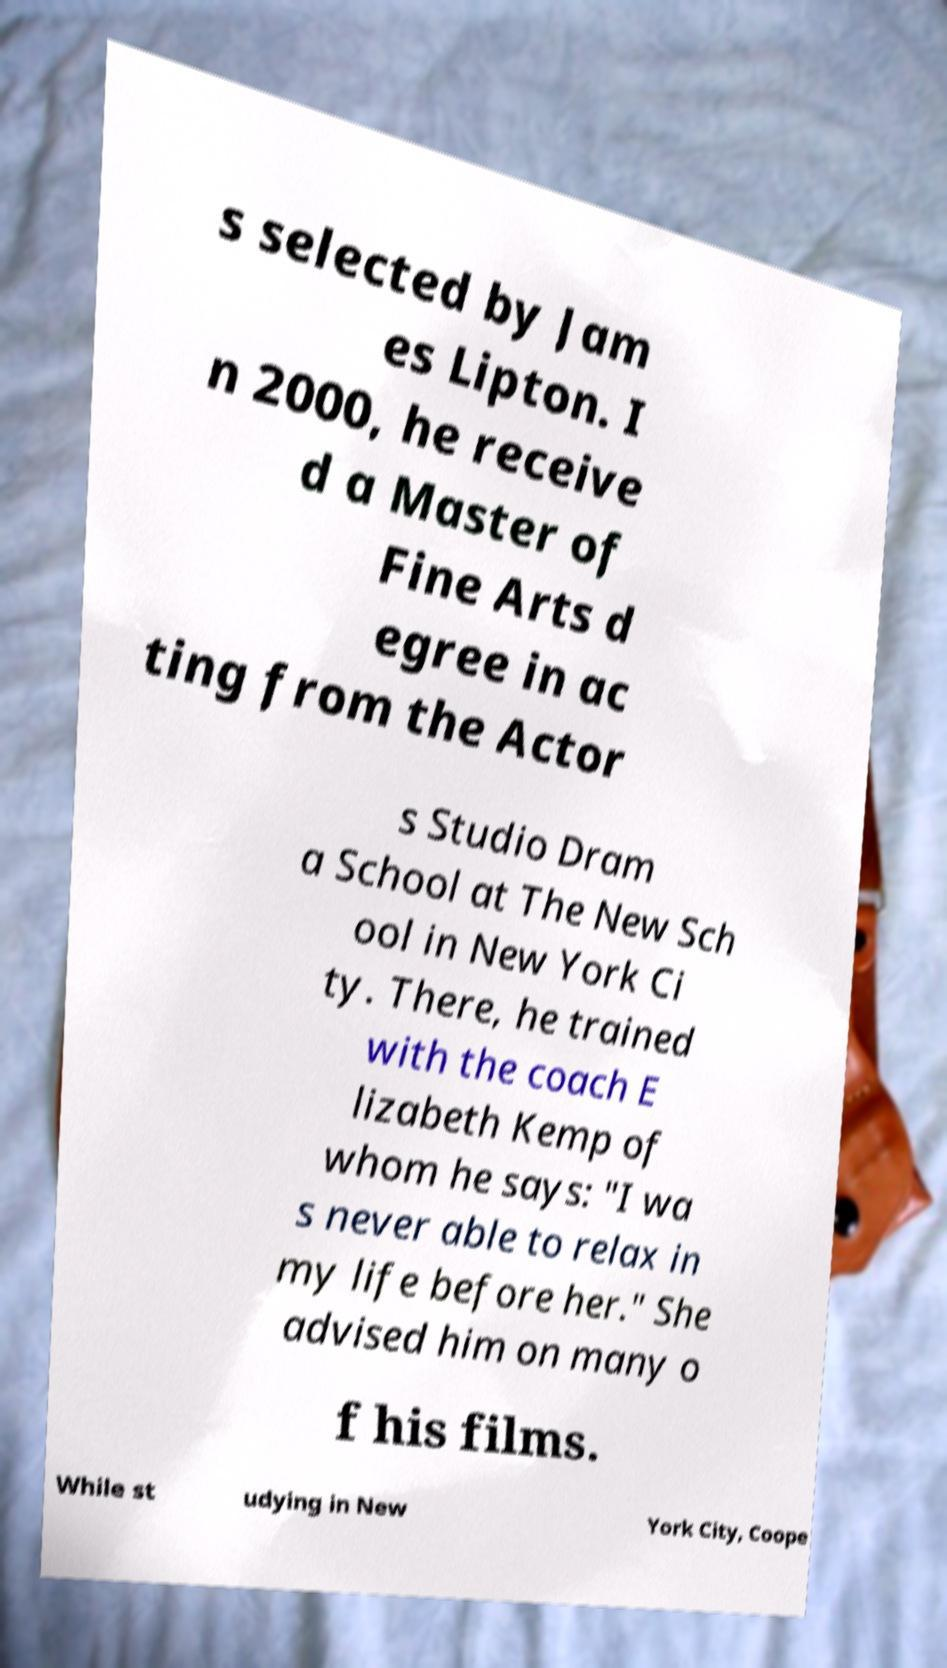There's text embedded in this image that I need extracted. Can you transcribe it verbatim? s selected by Jam es Lipton. I n 2000, he receive d a Master of Fine Arts d egree in ac ting from the Actor s Studio Dram a School at The New Sch ool in New York Ci ty. There, he trained with the coach E lizabeth Kemp of whom he says: "I wa s never able to relax in my life before her." She advised him on many o f his films. While st udying in New York City, Coope 